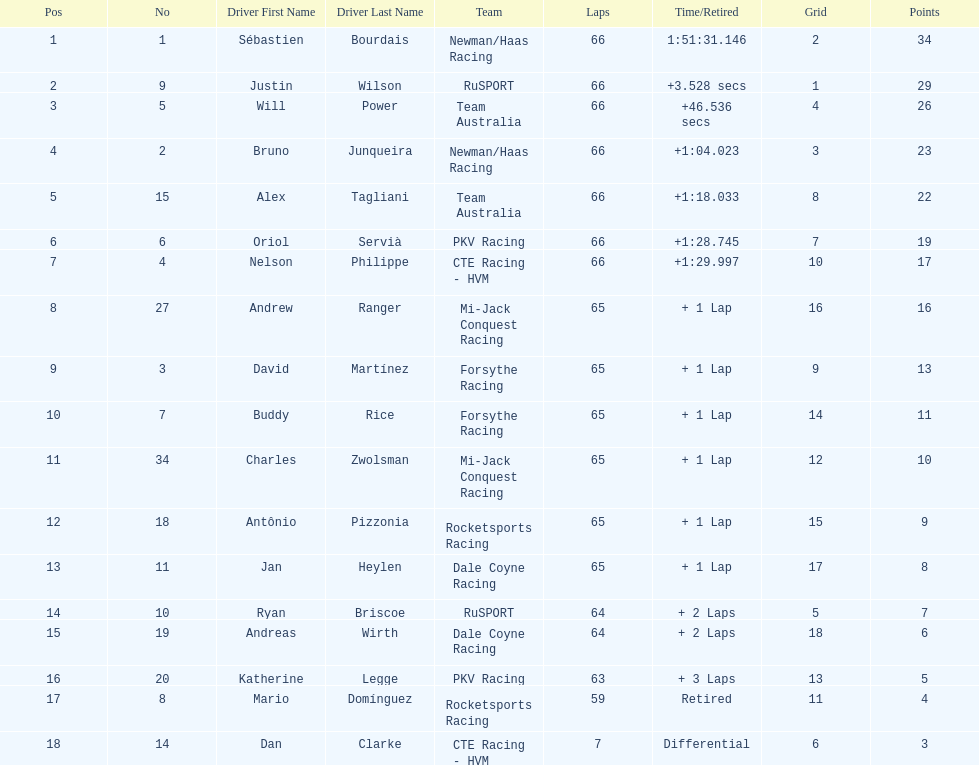At the 2006 gran premio telmex, how many drivers completed less than 60 laps? 2. 